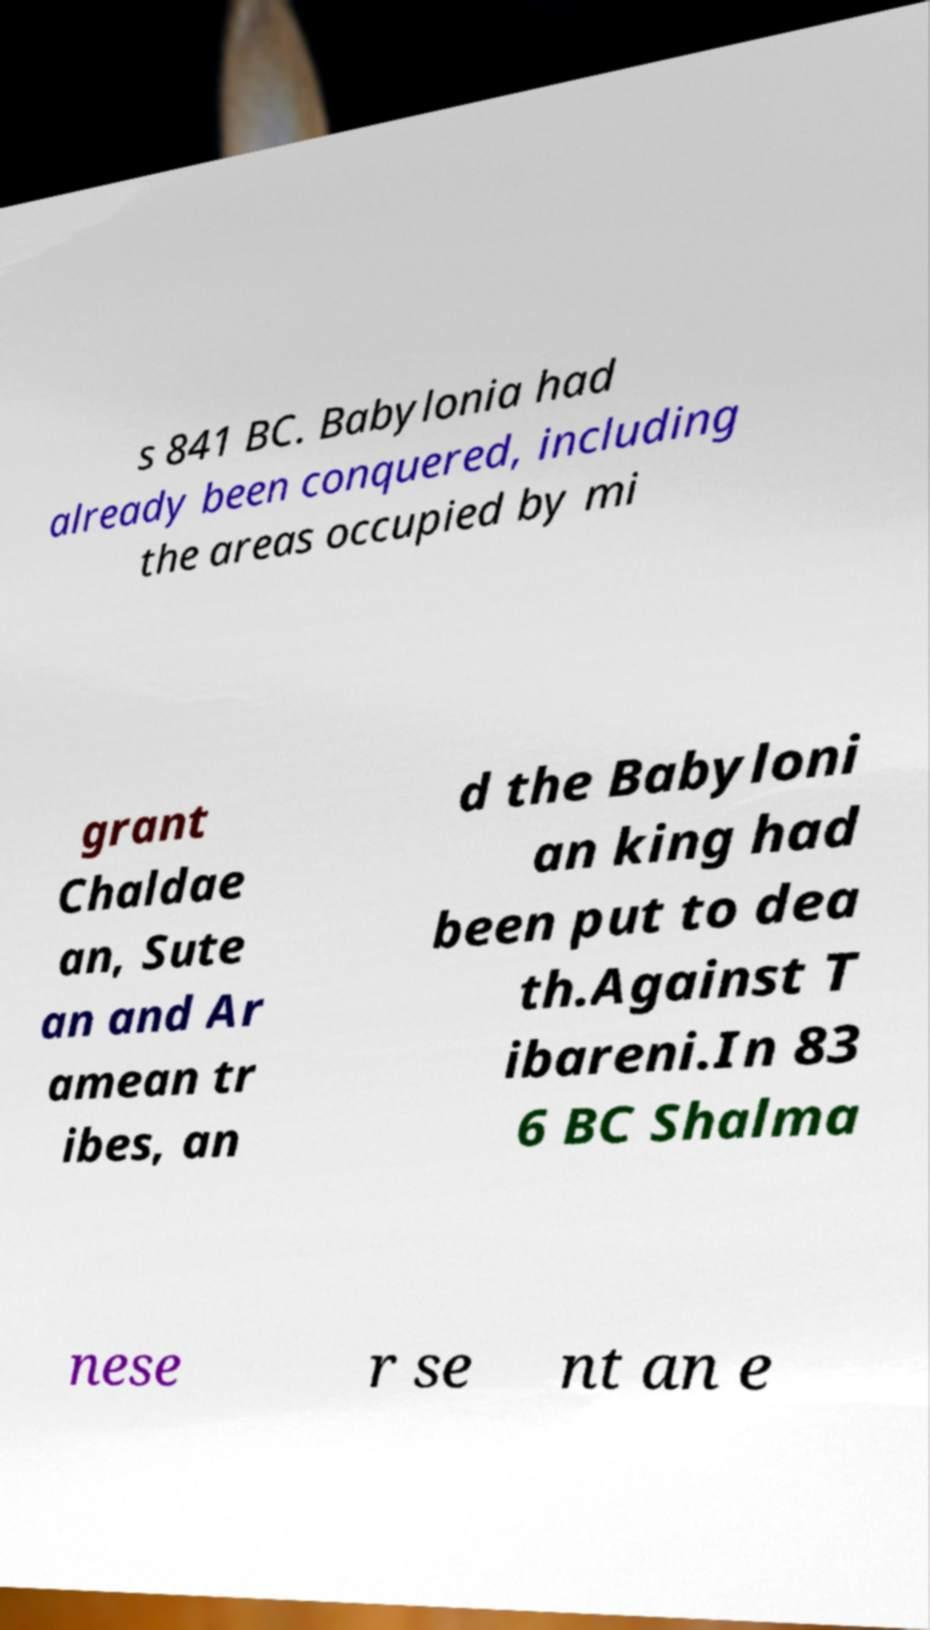What messages or text are displayed in this image? I need them in a readable, typed format. s 841 BC. Babylonia had already been conquered, including the areas occupied by mi grant Chaldae an, Sute an and Ar amean tr ibes, an d the Babyloni an king had been put to dea th.Against T ibareni.In 83 6 BC Shalma nese r se nt an e 